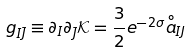<formula> <loc_0><loc_0><loc_500><loc_500>g _ { I \bar { J } } \equiv \partial _ { I } \partial _ { \bar { J } } \mathcal { K } = \frac { 3 } { 2 } e ^ { - 2 \sigma } { \stackrel { \circ } { a } } _ { I J }</formula> 